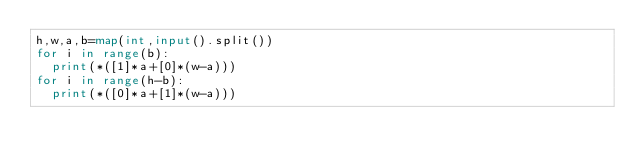<code> <loc_0><loc_0><loc_500><loc_500><_Python_>h,w,a,b=map(int,input().split())
for i in range(b):
  print(*([1]*a+[0]*(w-a)))
for i in range(h-b):
  print(*([0]*a+[1]*(w-a)))</code> 